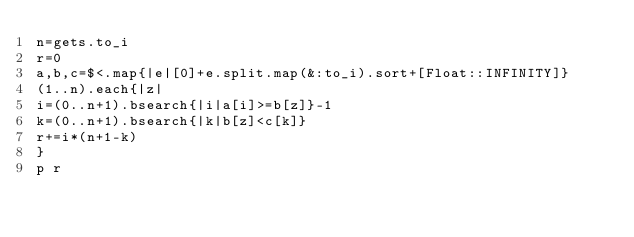Convert code to text. <code><loc_0><loc_0><loc_500><loc_500><_Ruby_>n=gets.to_i
r=0
a,b,c=$<.map{|e|[0]+e.split.map(&:to_i).sort+[Float::INFINITY]}
(1..n).each{|z|
i=(0..n+1).bsearch{|i|a[i]>=b[z]}-1
k=(0..n+1).bsearch{|k|b[z]<c[k]}
r+=i*(n+1-k)
}
p r</code> 